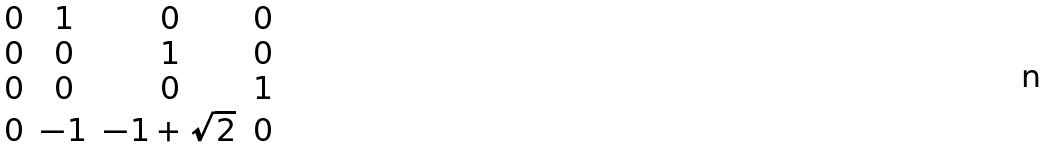Convert formula to latex. <formula><loc_0><loc_0><loc_500><loc_500>\begin{matrix} 0 & 1 & 0 & 0 \\ 0 & 0 & 1 & 0 \\ 0 & 0 & 0 & 1 \\ 0 & - 1 & - 1 + \sqrt { 2 } & 0 \end{matrix}</formula> 